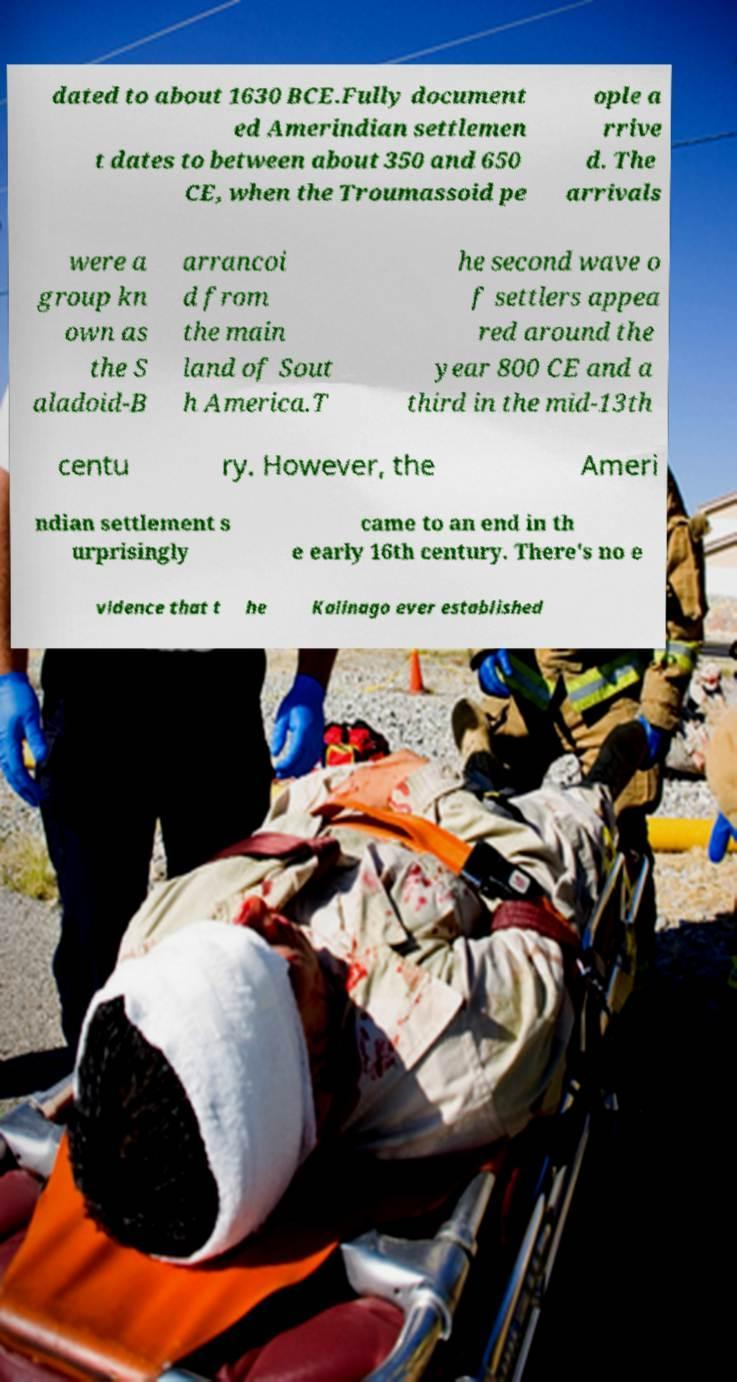Could you extract and type out the text from this image? dated to about 1630 BCE.Fully document ed Amerindian settlemen t dates to between about 350 and 650 CE, when the Troumassoid pe ople a rrive d. The arrivals were a group kn own as the S aladoid-B arrancoi d from the main land of Sout h America.T he second wave o f settlers appea red around the year 800 CE and a third in the mid-13th centu ry. However, the Ameri ndian settlement s urprisingly came to an end in th e early 16th century. There's no e vidence that t he Kalinago ever established 